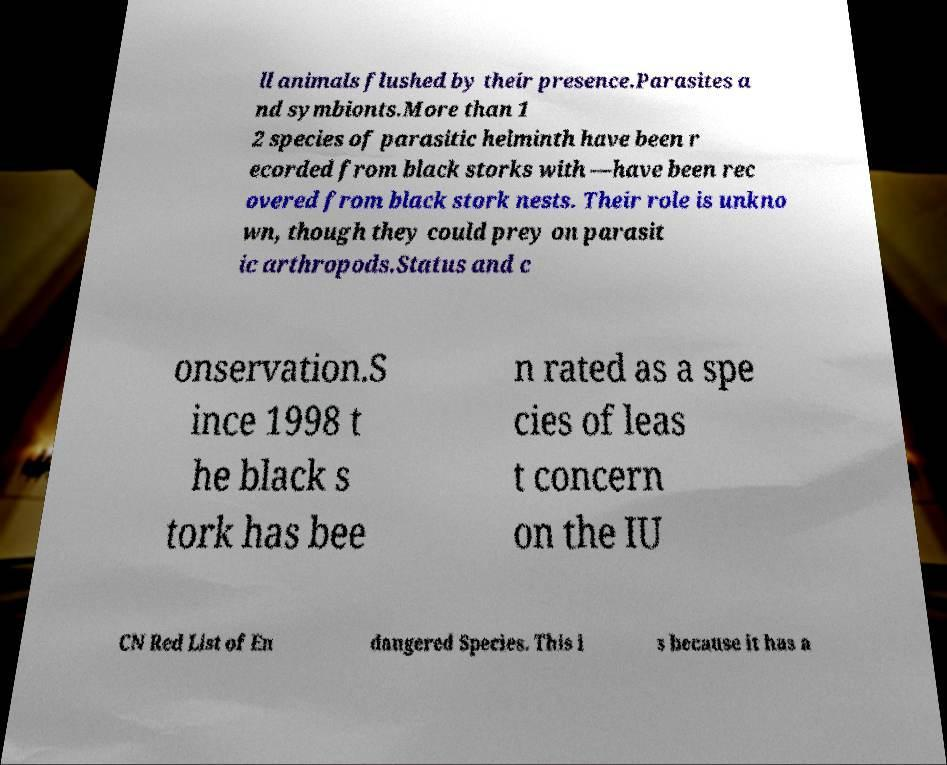Please read and relay the text visible in this image. What does it say? ll animals flushed by their presence.Parasites a nd symbionts.More than 1 2 species of parasitic helminth have been r ecorded from black storks with —have been rec overed from black stork nests. Their role is unkno wn, though they could prey on parasit ic arthropods.Status and c onservation.S ince 1998 t he black s tork has bee n rated as a spe cies of leas t concern on the IU CN Red List of En dangered Species. This i s because it has a 